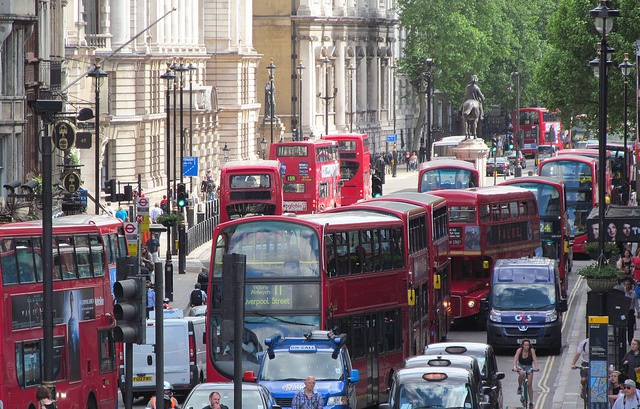Describe the objects in this image and their specific colors. I can see bus in gray, black, maroon, and darkgray tones, bus in gray, brown, and black tones, bus in gray, black, maroon, and purple tones, bus in gray, black, maroon, and darkgray tones, and car in gray, darkgray, and navy tones in this image. 